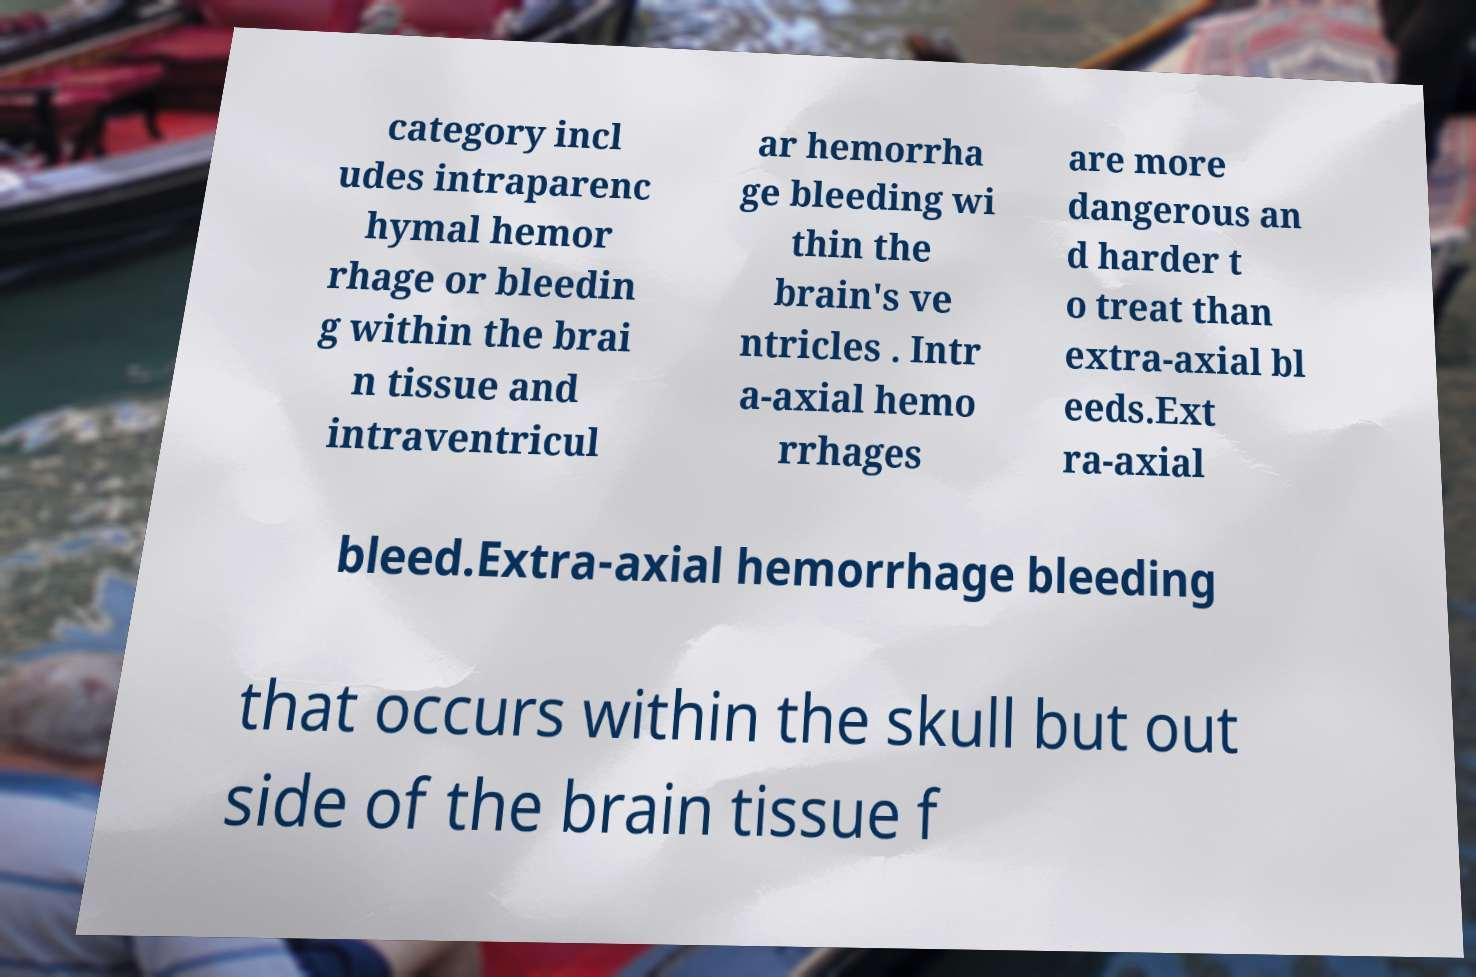For documentation purposes, I need the text within this image transcribed. Could you provide that? category incl udes intraparenc hymal hemor rhage or bleedin g within the brai n tissue and intraventricul ar hemorrha ge bleeding wi thin the brain's ve ntricles . Intr a-axial hemo rrhages are more dangerous an d harder t o treat than extra-axial bl eeds.Ext ra-axial bleed.Extra-axial hemorrhage bleeding that occurs within the skull but out side of the brain tissue f 